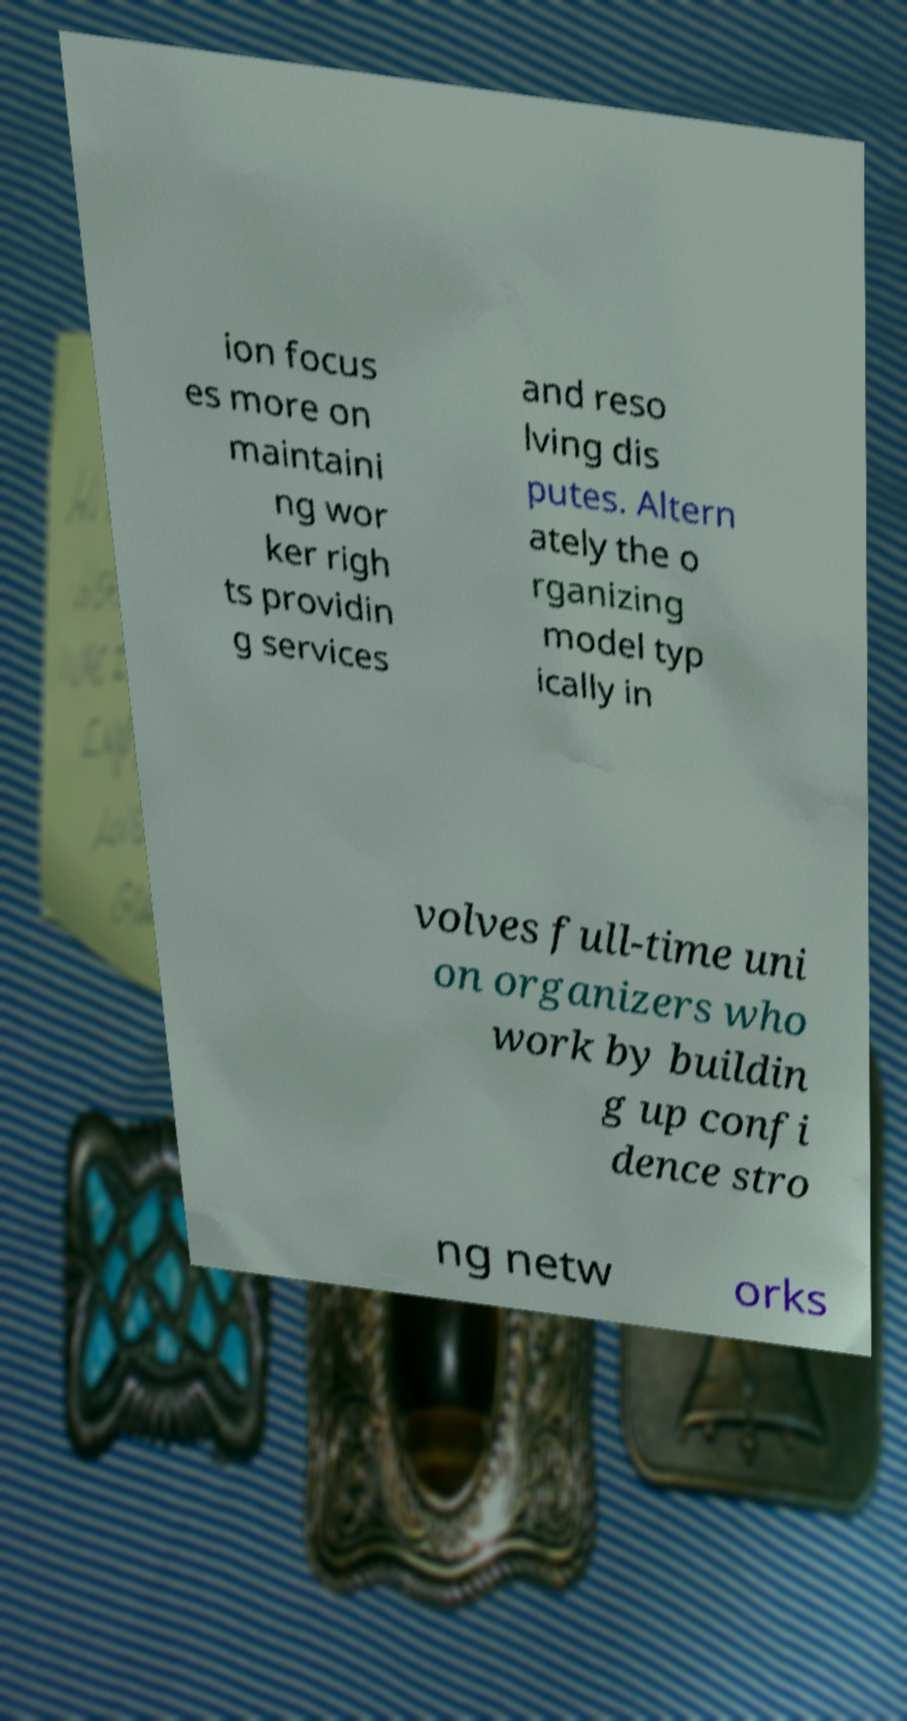For documentation purposes, I need the text within this image transcribed. Could you provide that? ion focus es more on maintaini ng wor ker righ ts providin g services and reso lving dis putes. Altern ately the o rganizing model typ ically in volves full-time uni on organizers who work by buildin g up confi dence stro ng netw orks 